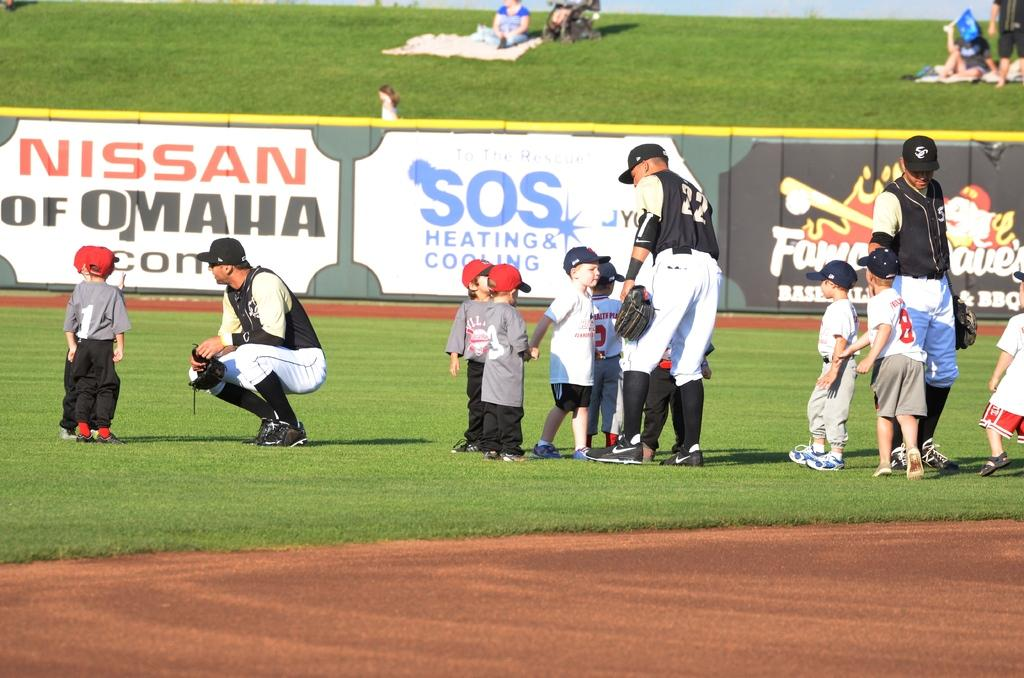<image>
Offer a succinct explanation of the picture presented. A baseball team talks to a number of small children on a field in front of signs bearing the names Nissan and SOS heating & cooling. 